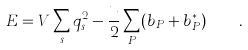<formula> <loc_0><loc_0><loc_500><loc_500>E = V \sum _ { s } q _ { s } ^ { 2 } - \frac { u } { 2 } \sum _ { P } ( b _ { P } + b _ { P } ^ { * } ) \quad .</formula> 